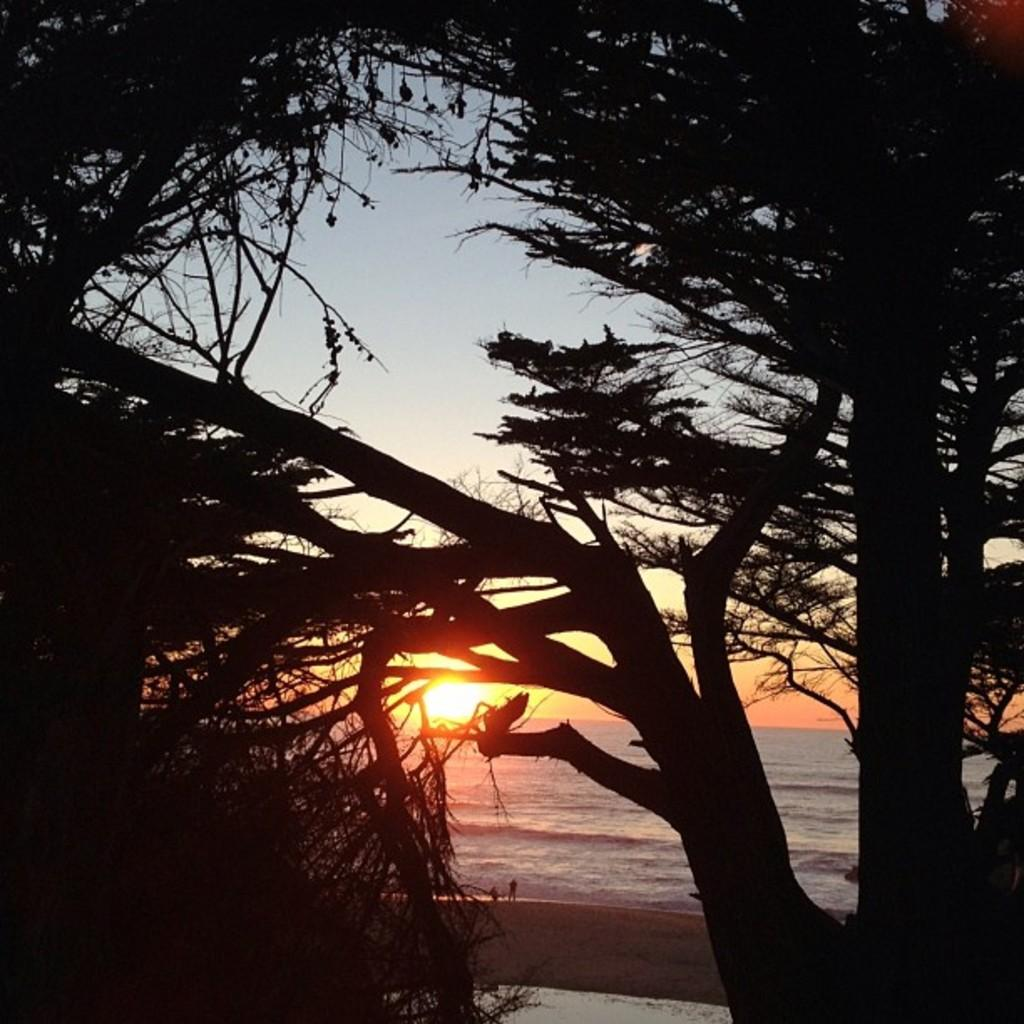What type of vegetation is in the foreground of the image? There are trees in the foreground of the image. What type of location does the image appear to depict? The image appears to depict a beach setting. What can be seen in the background of the image? There is water visible in the background of the image. How many people are present in the image? There are two persons standing in the background. What is visible in the sky in the image? The sun is observable in the sky. What type of yard is visible in the image? There is no yard present in the image; it depicts a beach setting with trees, water, and people. Is there a scarf being used by one of the persons in the image? There is no mention of a scarf in the provided facts, so it cannot be determined if one is present or being used. 